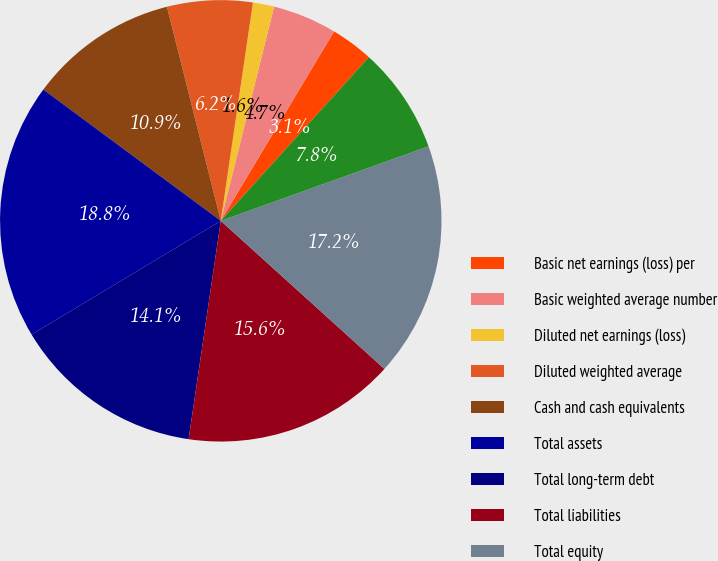<chart> <loc_0><loc_0><loc_500><loc_500><pie_chart><fcel>Basic net earnings (loss) per<fcel>Basic weighted average number<fcel>Diluted net earnings (loss)<fcel>Diluted weighted average<fcel>Cash and cash equivalents<fcel>Total assets<fcel>Total long-term debt<fcel>Total liabilities<fcel>Total equity<fcel>Depreciation depletion and<nl><fcel>3.13%<fcel>4.69%<fcel>1.56%<fcel>6.25%<fcel>10.94%<fcel>18.75%<fcel>14.06%<fcel>15.62%<fcel>17.19%<fcel>7.81%<nl></chart> 